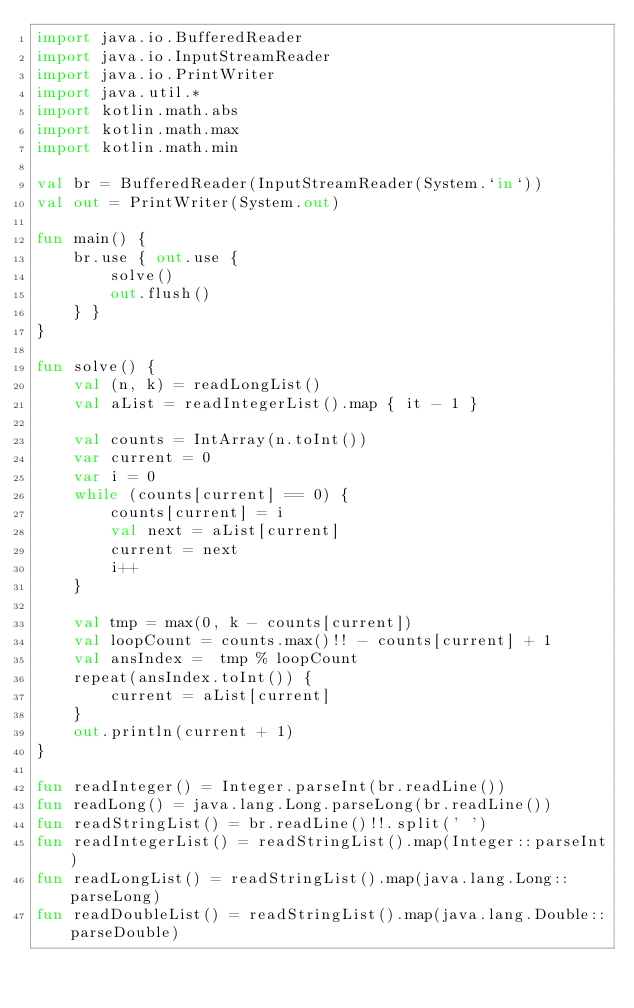<code> <loc_0><loc_0><loc_500><loc_500><_Kotlin_>import java.io.BufferedReader
import java.io.InputStreamReader
import java.io.PrintWriter
import java.util.*
import kotlin.math.abs
import kotlin.math.max
import kotlin.math.min

val br = BufferedReader(InputStreamReader(System.`in`))
val out = PrintWriter(System.out)

fun main() {
    br.use { out.use {
        solve()
        out.flush()
    } }
}

fun solve() {
    val (n, k) = readLongList()
    val aList = readIntegerList().map { it - 1 }

    val counts = IntArray(n.toInt())
    var current = 0
    var i = 0
    while (counts[current] == 0) {
        counts[current] = i
        val next = aList[current]
        current = next
        i++
    }

    val tmp = max(0, k - counts[current])
    val loopCount = counts.max()!! - counts[current] + 1
    val ansIndex =  tmp % loopCount
    repeat(ansIndex.toInt()) {
        current = aList[current]
    }
    out.println(current + 1)
}

fun readInteger() = Integer.parseInt(br.readLine())
fun readLong() = java.lang.Long.parseLong(br.readLine())
fun readStringList() = br.readLine()!!.split(' ')
fun readIntegerList() = readStringList().map(Integer::parseInt)
fun readLongList() = readStringList().map(java.lang.Long::parseLong)
fun readDoubleList() = readStringList().map(java.lang.Double::parseDouble)
</code> 